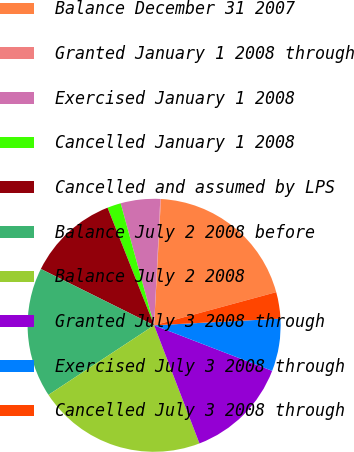Convert chart to OTSL. <chart><loc_0><loc_0><loc_500><loc_500><pie_chart><fcel>Balance December 31 2007<fcel>Granted January 1 2008 through<fcel>Exercised January 1 2008<fcel>Cancelled January 1 2008<fcel>Cancelled and assumed by LPS<fcel>Balance July 2 2008 before<fcel>Balance July 2 2008<fcel>Granted July 3 2008 through<fcel>Exercised July 3 2008 through<fcel>Cancelled July 3 2008 through<nl><fcel>19.92%<fcel>0.08%<fcel>5.04%<fcel>1.74%<fcel>11.65%<fcel>16.61%<fcel>21.57%<fcel>13.31%<fcel>6.69%<fcel>3.39%<nl></chart> 